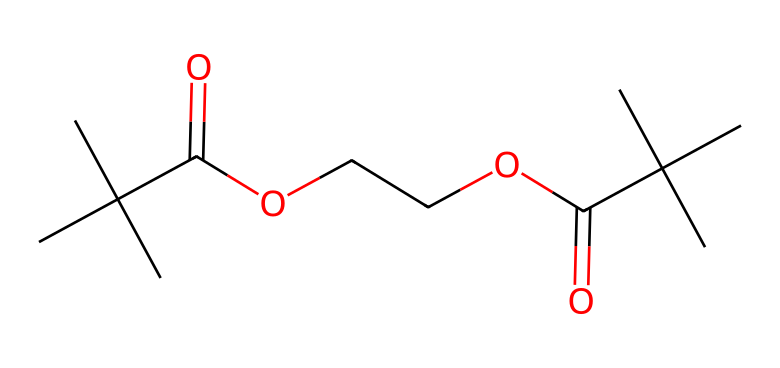What is the main functional group present in this structure? The structure contains a carboxylic acid group, which is indicated by the presence of the -COOH moiety. The presence of this functional group is crucial in chemical classification.
Answer: carboxylic acid How many carbon atoms are in this compound? By analyzing the SMILES representation, there are 10 carbon atoms indicated in the structure with their respective connections, including the branches.
Answer: 10 What type of bonds are primarily found in this aliphatic compound? The primary types of bonds in this structure are single bonds (sigma bonds), which are typical in aliphatic compounds, as they do not contain any double or triple bonds in the main chain.
Answer: single bonds Does this compound have any cyclic structures? The SMILES representation shows only linear chains with branches, indicating there are no loops or cyclic structures present in this compound.
Answer: no What is the number of oxygen atoms in the molecule? The analysis of the structure reveals that there are 4 oxygen atoms present, as seen in both the carboxylic and ether functional groups indicated in the SMILES representation.
Answer: 4 How many ester functional groups can be identified in the compound? The structure has two ester functional groups, as indicated by the presence of -COOR (where R is an alkyl chain) in the molecular arrangement. Each is connected to carbon chains on both sides.
Answer: 2 